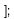<code> <loc_0><loc_0><loc_500><loc_500><_JavaScript_>];</code> 